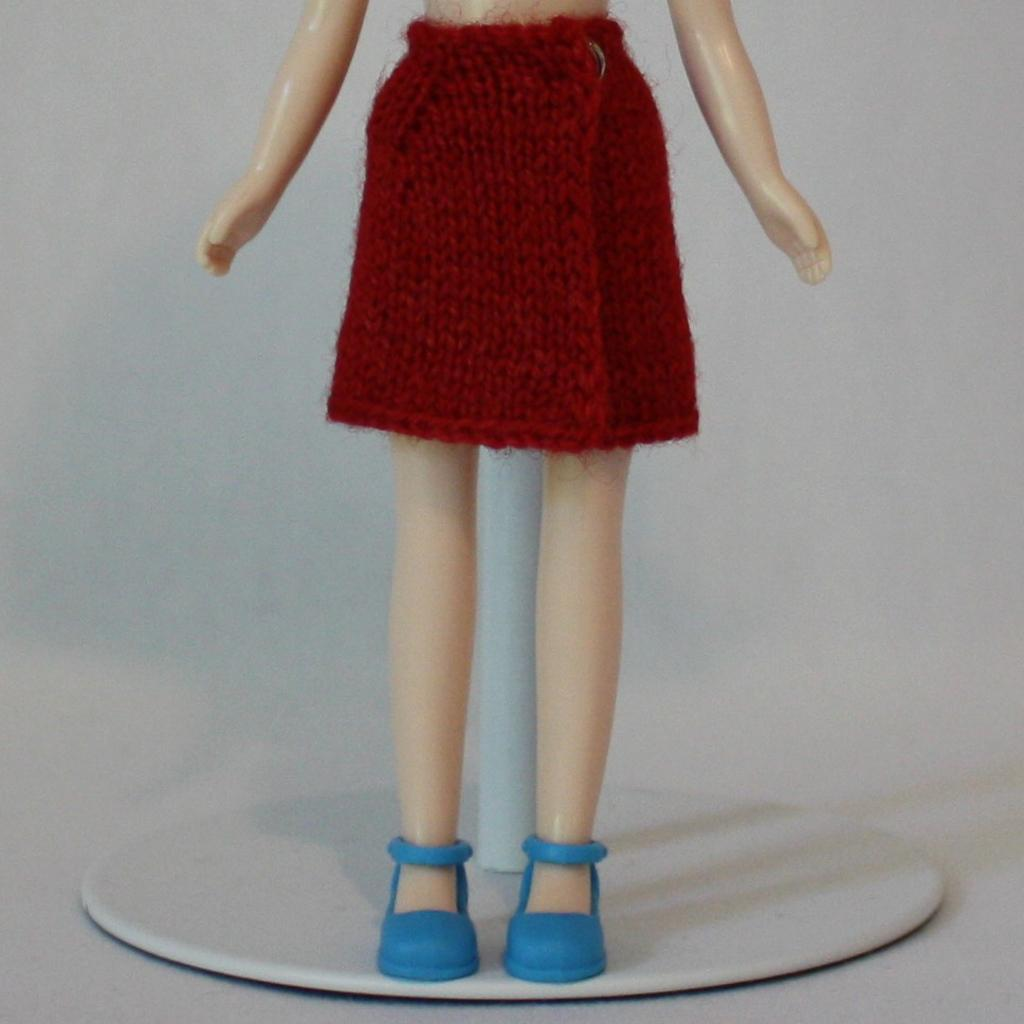What type of object is standing in the image? There is a standing toy in the image. What is the toy wearing? The toy is wearing a skirt. Is the girl wearing a mitten in the image? There is no girl present in the image, only a standing toy wearing a skirt. 